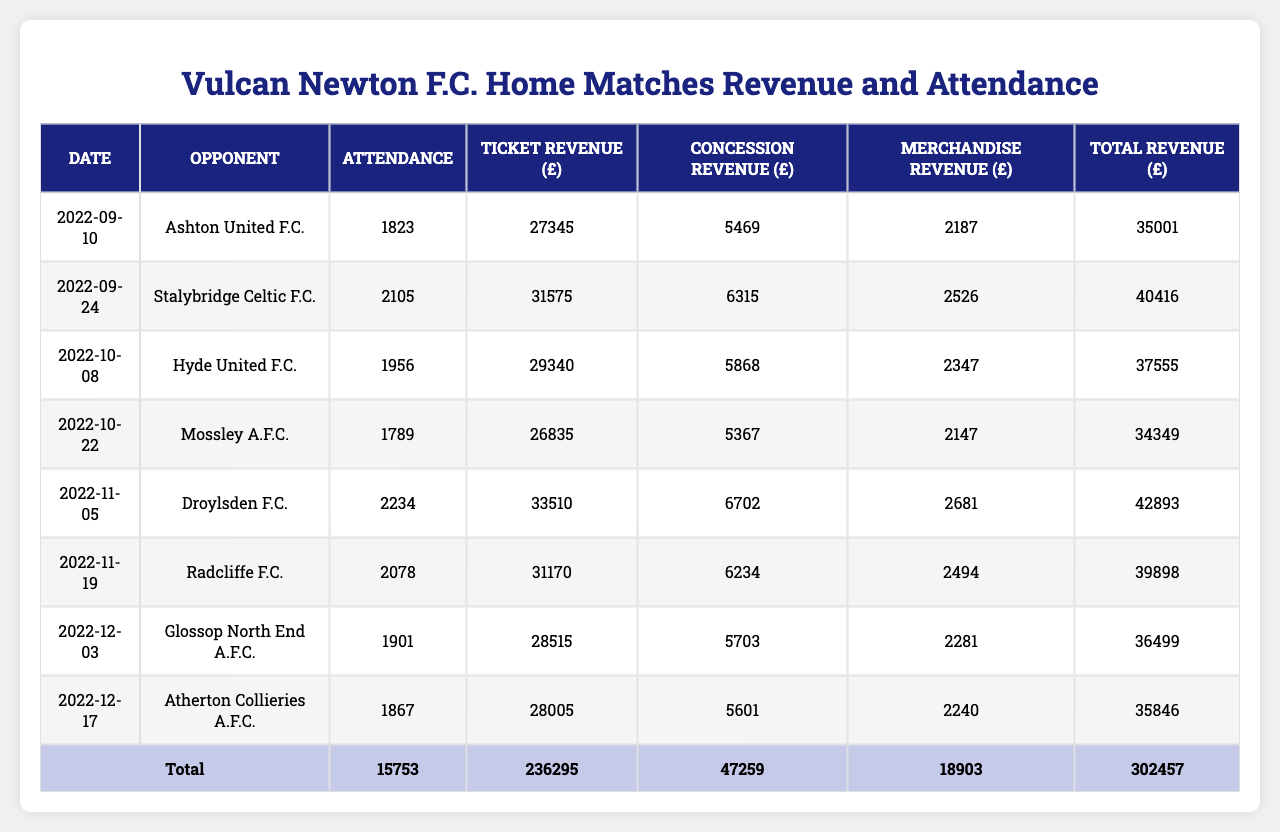What was the total attendance across all matches? To find the total attendance, we sum the attendance figures from all the matches: 1823 + 2105 + 1956 + 1789 + 2234 + 2078 + 1901 + 1867 = 14,053.
Answer: 14053 Which match had the highest ticket revenue? Looking at the ticket revenue column, the highest value is 33,510 from the match against Droylsden F.C. on 2022-11-05.
Answer: 33,510 What is the total revenue from concessions for all matches? We sum the concession revenues for all matches: 5469 + 6315 + 5868 + 5367 + 6702 + 6234 + 5703 + 5601 = 45,164.
Answer: 45164 Did Vulcan Newton F.C. have more than 2,000 attendees in any match? By reviewing the attendance figures, the matches against Droylsden F.C. (2234) and Stalybridge Celtic F.C. (2105) exceed 2,000 attendees.
Answer: Yes What is the average merchandise revenue per match? To find the average, sum up the merchandise revenue: 2187 + 2526 + 2347 + 2147 + 2681 + 2494 + 2281 + 2240 = 17,902, then divide by the number of matches (8): 17,902 / 8 = 2,237.75.
Answer: 2237.75 Which match had the lowest attendance? The match with the lowest attendance had 1,789 attendees, which was against Mossley A.F.C. on 2022-10-22.
Answer: 1789 What was the total revenue from all matches? We calculate the total revenue by summing each match's total revenue: (27345 + 5469 + 2187) + (31575 + 6315 + 2526) + (29340 + 5868 + 2347) + (26835 + 5367 + 2147) + (33510 + 6702 + 2681) + (31170 + 6234 + 2494) + (28515 + 5703 + 2281) + (28005 + 5601 + 2240) = 240,723.
Answer: 240723 Was the ticket revenue from the match against Radcliffe F.C. higher than 30,000? The ticket revenue for the match against Radcliffe F.C. is 31,170, which is indeed higher than 30,000.
Answer: Yes What is the difference between the highest and the lowest merchandise revenue? The highest merchandise revenue is 2,681 from the match against Droylsden F.C., and the lowest is 2,187 from the match against Ashton United F.C., giving a difference of 2681 - 2187 = 494.
Answer: 494 How many matches had an attendance below the average attendance? The average attendance is 14,053 / 8 = 1,756.625. The matches with attendance below this average are: Ashton United F.C. (1823), Hyde United F.C. (1956), Mossley A.F.C. (1789), and Atherton Collieries A.F.C. (1867), totaling 4 matches.
Answer: 4 